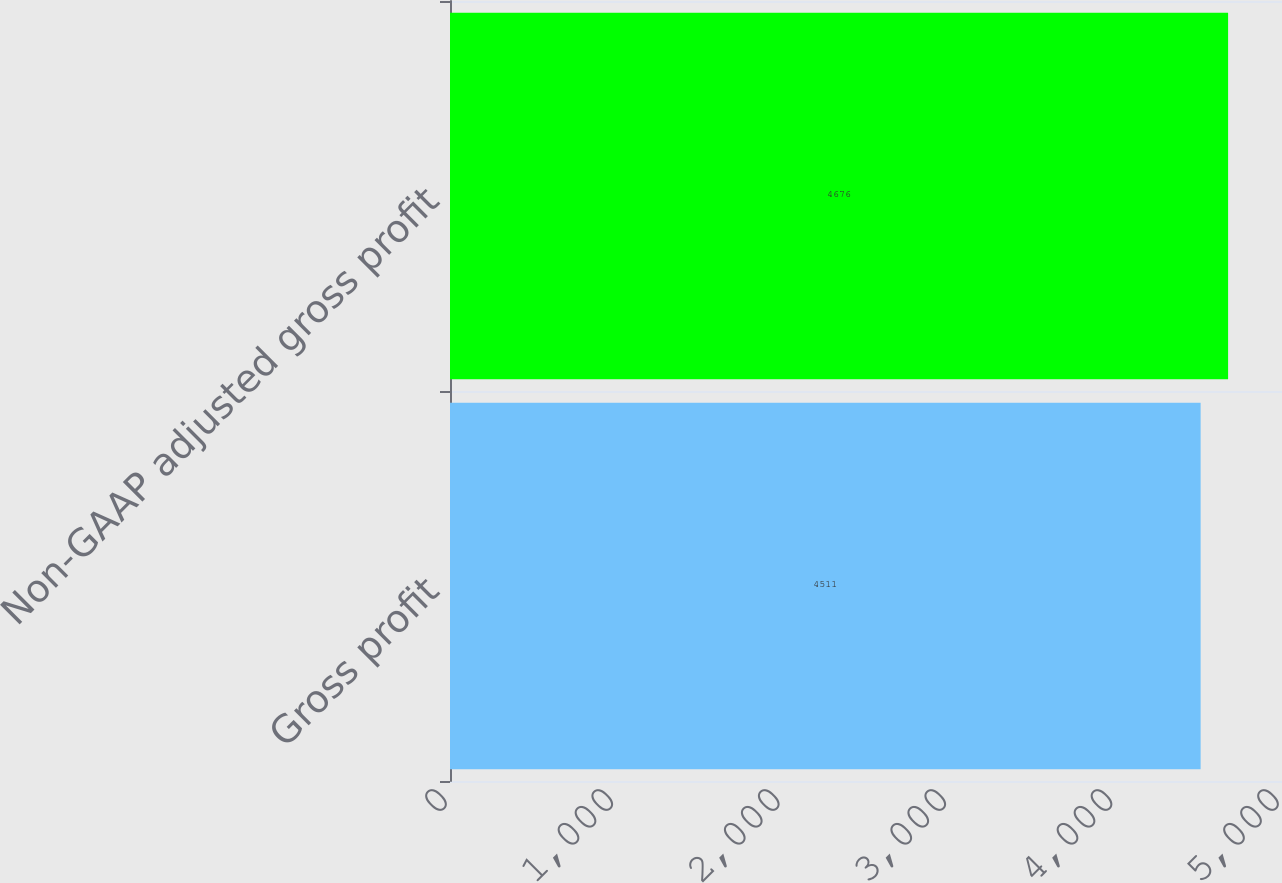<chart> <loc_0><loc_0><loc_500><loc_500><bar_chart><fcel>Gross profit<fcel>Non-GAAP adjusted gross profit<nl><fcel>4511<fcel>4676<nl></chart> 